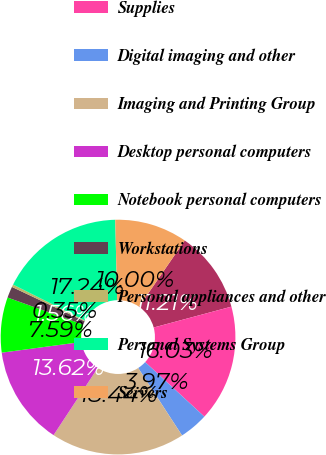<chart> <loc_0><loc_0><loc_500><loc_500><pie_chart><fcel>Printer hardware<fcel>Supplies<fcel>Digital imaging and other<fcel>Imaging and Printing Group<fcel>Desktop personal computers<fcel>Notebook personal computers<fcel>Workstations<fcel>Personal appliances and other<fcel>Personal Systems Group<fcel>Servers<nl><fcel>11.21%<fcel>16.03%<fcel>3.97%<fcel>18.44%<fcel>13.62%<fcel>7.59%<fcel>1.56%<fcel>0.35%<fcel>17.24%<fcel>10.0%<nl></chart> 